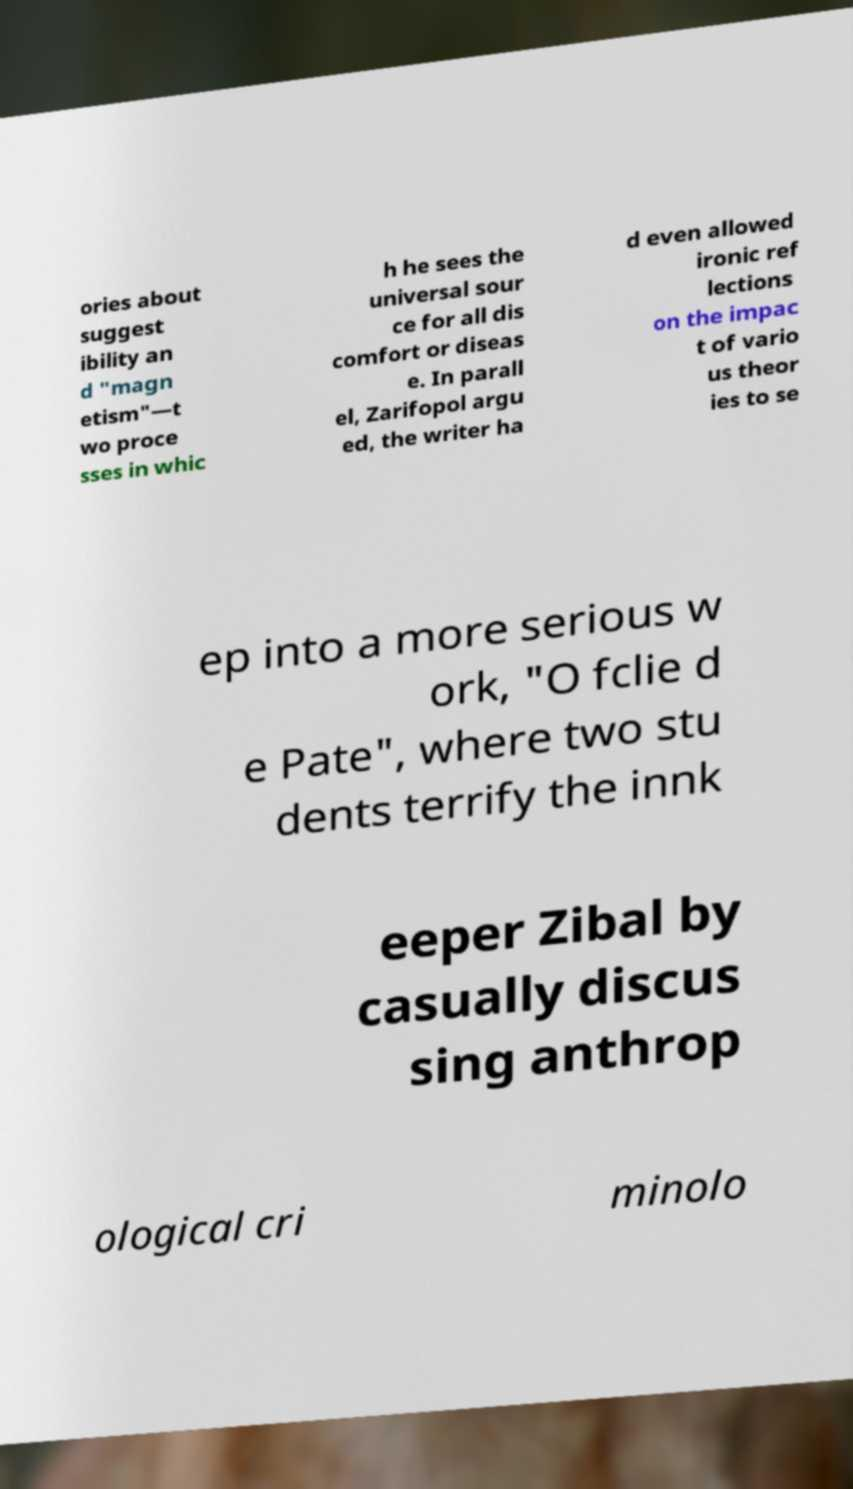I need the written content from this picture converted into text. Can you do that? ories about suggest ibility an d "magn etism"—t wo proce sses in whic h he sees the universal sour ce for all dis comfort or diseas e. In parall el, Zarifopol argu ed, the writer ha d even allowed ironic ref lections on the impac t of vario us theor ies to se ep into a more serious w ork, "O fclie d e Pate", where two stu dents terrify the innk eeper Zibal by casually discus sing anthrop ological cri minolo 